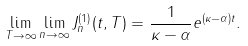<formula> <loc_0><loc_0><loc_500><loc_500>\lim _ { T \to \infty } \lim _ { n \to \infty } J _ { n } ^ { ( 1 ) } ( t , T ) = \frac { 1 } { \kappa - \alpha } e ^ { ( \kappa - \alpha ) t } .</formula> 